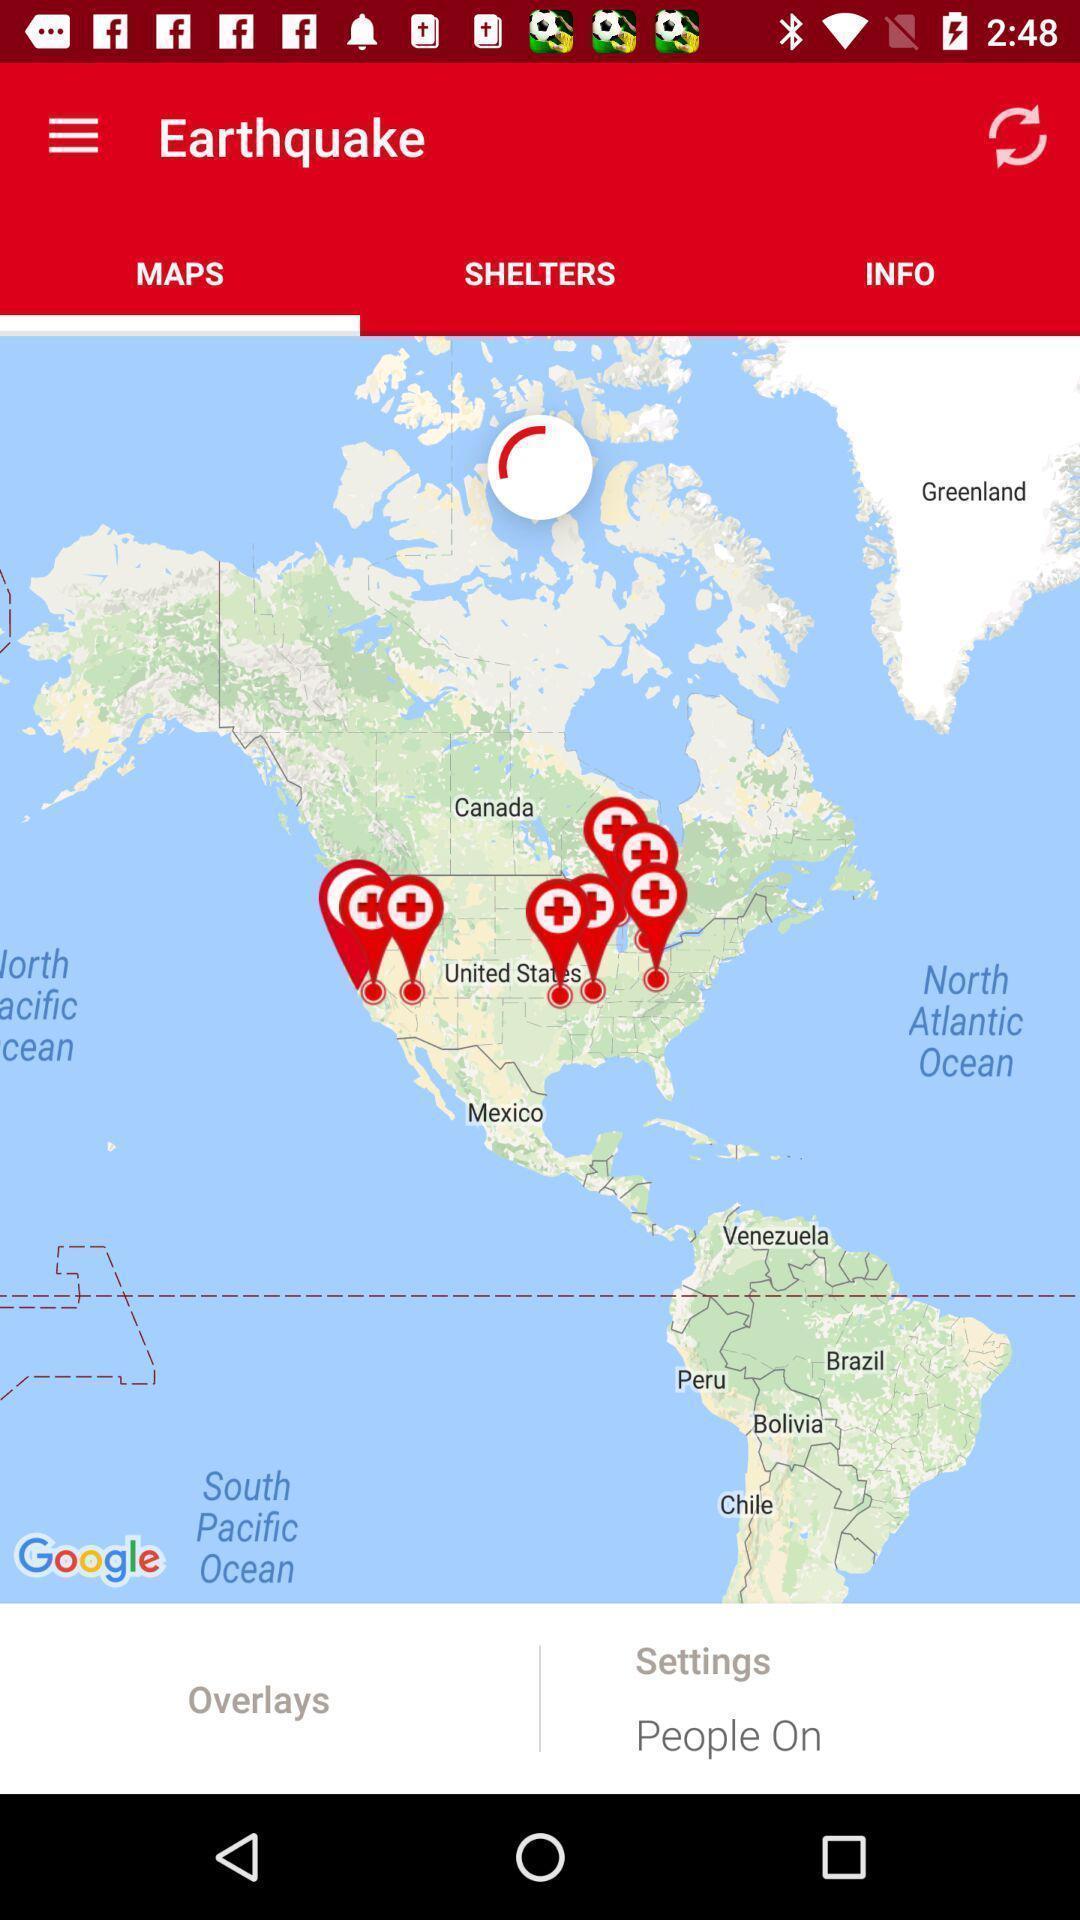Explain the elements present in this screenshot. Page showing earthquake hit areas in map. 